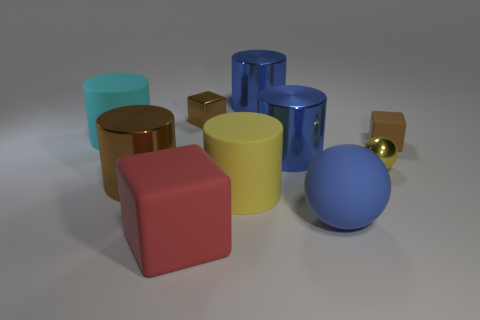Subtract all large cyan cylinders. How many cylinders are left? 4 Subtract all yellow cylinders. How many cylinders are left? 4 Subtract all gray cylinders. Subtract all gray spheres. How many cylinders are left? 5 Subtract all blocks. How many objects are left? 7 Subtract 1 blue cylinders. How many objects are left? 9 Subtract all blue balls. Subtract all big metallic spheres. How many objects are left? 9 Add 5 big red rubber objects. How many big red rubber objects are left? 6 Add 7 small gray metallic things. How many small gray metallic things exist? 7 